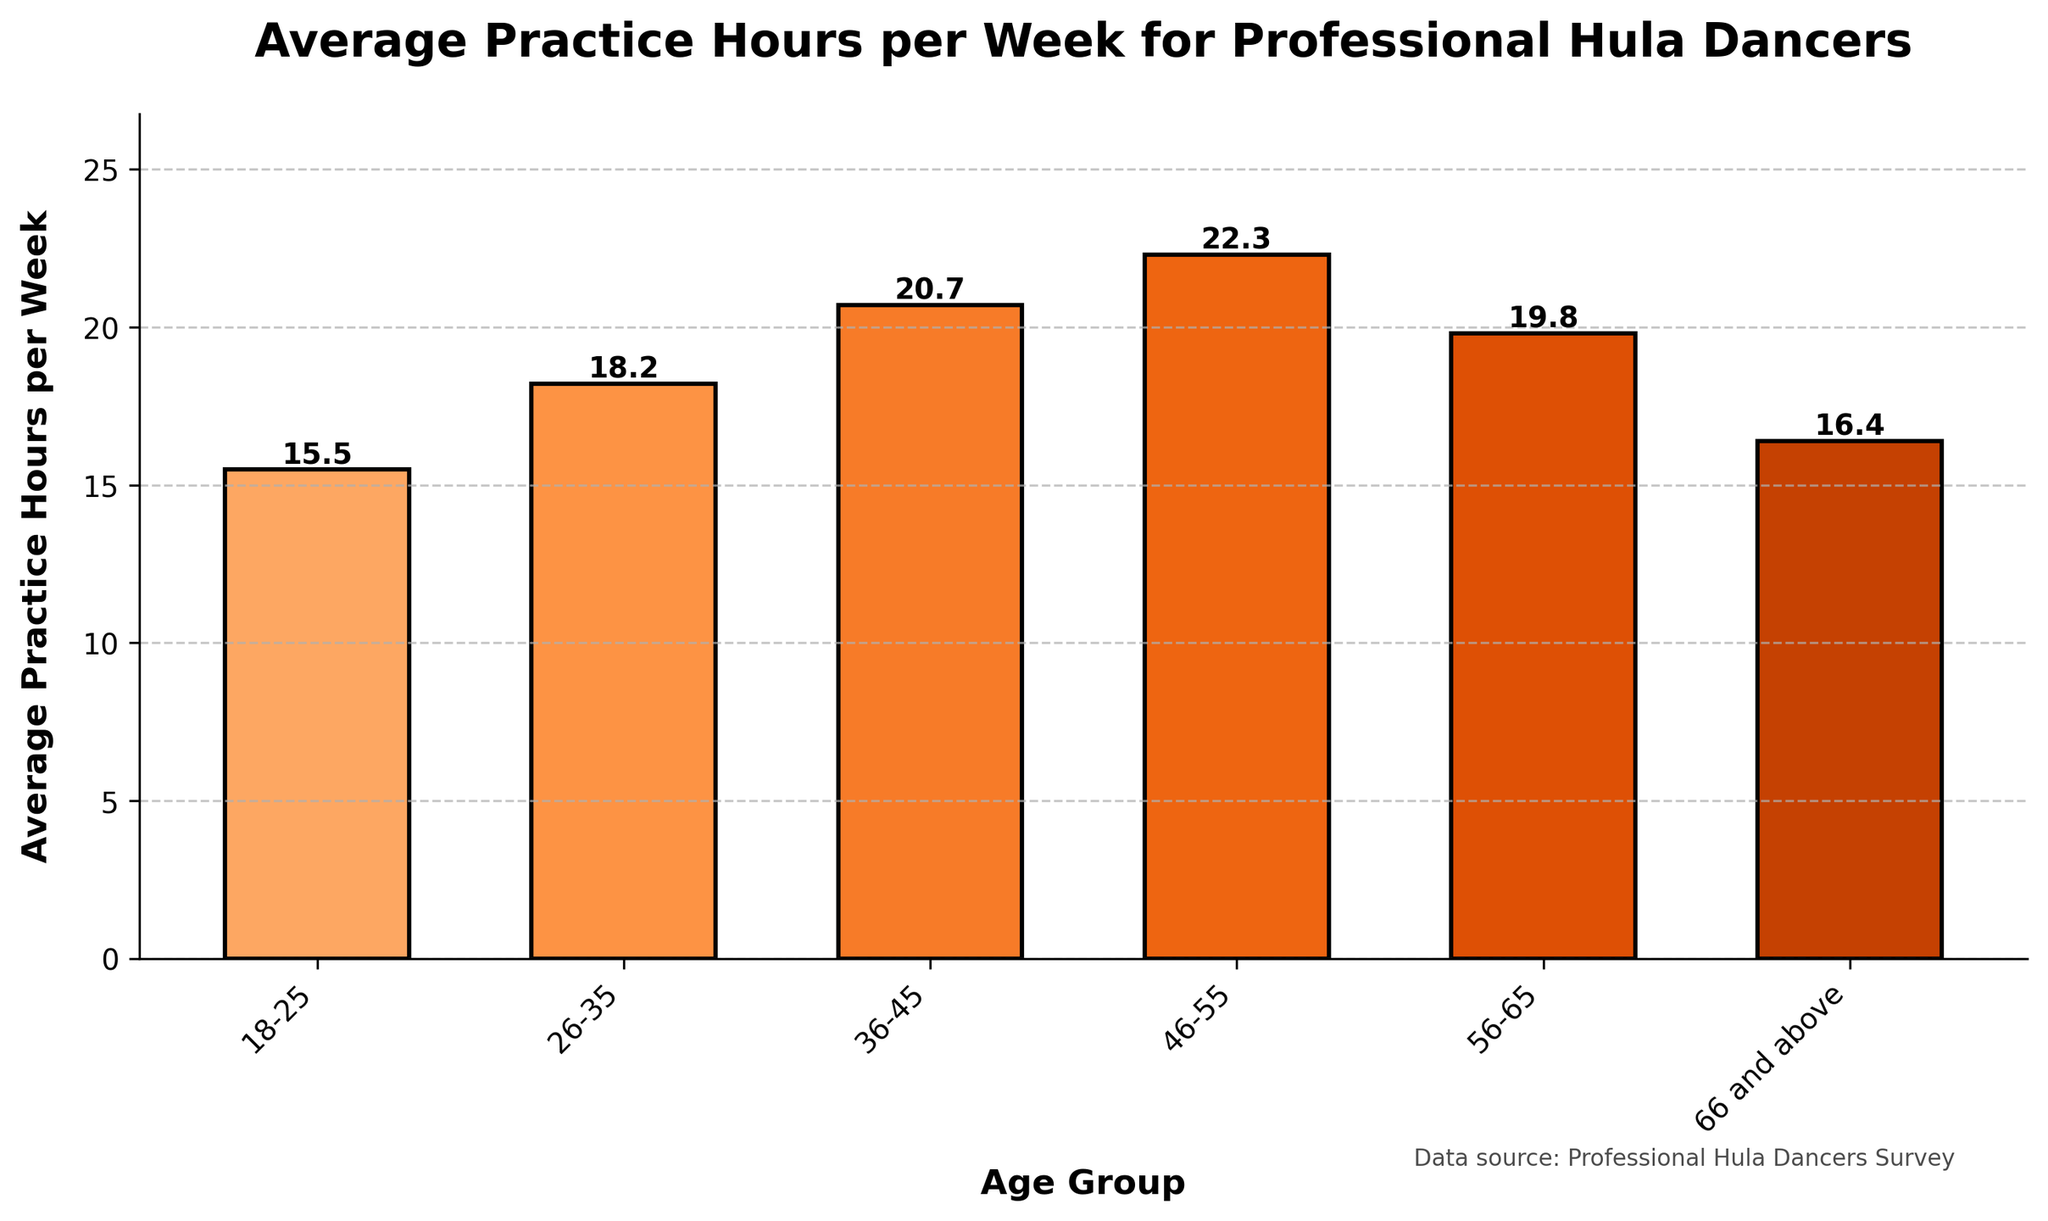What is the average practice hours per week for the 46-55 age group? Look at the bar corresponding to the 46-55 age group and read the height value.
Answer: 22.3 Which age group practices the most per week on average? Identify the tallest bar in the plot, corresponding to the age group with the highest practice hours.
Answer: 46-55 How does the average practice hours for the 18-25 age group compare to the 66 and above age group? Compare the heights of the bars for the 18-25 and 66 and above age groups. Note that the 18-25 age group practices 15.5 hours weekly, while the 66 and above group practices 16.4 hours weekly. Hence, the 66 and above group practices more.
Answer: 66 and above practices more What is the total average practice hours per week for all the age groups combined? Sum the average practice hours per week for all age groups: 15.5 + 18.2 + 20.7 + 22.3 + 19.8 + 16.4. Calculate the sum to get the total.
Answer: 112.9 How much more does the 36-45 age group practice compared to the 18-25 age group? Subtract the average practice hours of the 18-25 age group from the 36-45 age group: 20.7 - 15.5. The difference is the amount more that the 36-45 age group practices.
Answer: 5.2 Which age group has the least average practice hours per week? Identify the shortest bar in the plot, which represents the age group with the fewest practice hours.
Answer: 18-25 What is the range of average practice hours per week among all age groups? Subtract the average practice hours of the age group with the least hours from the group with the most hours: 22.3 - 15.5. The range in practice hours is the difference between these values.
Answer: 6.8 Are there any age groups whose practice hours are below the average of all groups combined? First calculate the average practice hours across all groups: (15.5 + 18.2 + 20.7 + 22.3 + 19.8 + 16.4) / 6 = 18.8. Then compare each group's practice hours to this average.
Answer: 18-25 and 66 and above How do the average practice hours for the 26-35 age group and 56-65 age group compare? Compare the heights of the bars for the 26-35 and 56-65 age groups. The average practice hours for the 26-35 age group is 18.2, while the 56-65 age group is 19.8.
Answer: 56-65 practices more Which age group shows a drop in practice hours compared to the previous age group? Examine the bars sequentially to find where an age group's practice hours are lower than the preceding age group. The 56-65 group drops from 22.3 hours from the previous 46-55 group's hours.
Answer: 56-65 